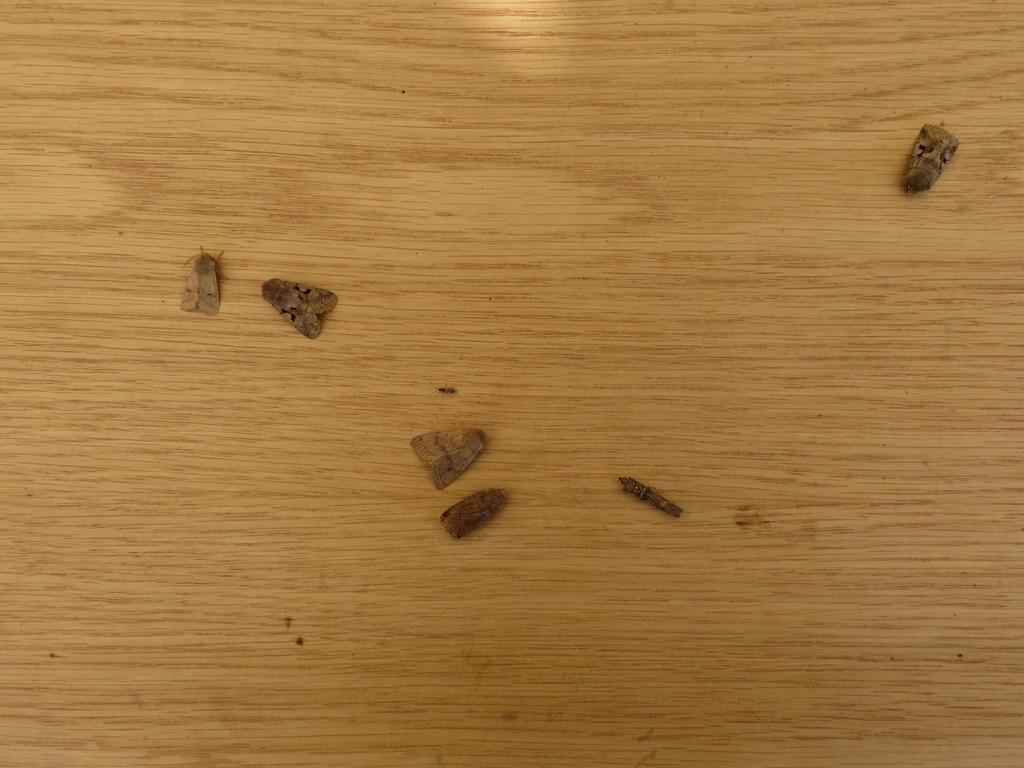In one or two sentences, can you explain what this image depicts? In this image we can see there are insects on the table. 